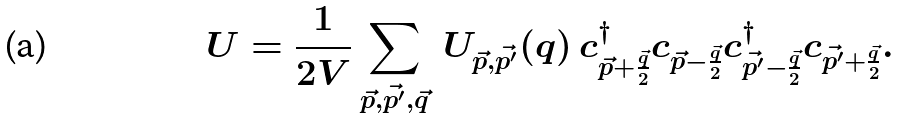<formula> <loc_0><loc_0><loc_500><loc_500>U = \frac { 1 } { 2 V } \sum _ { \vec { p } , \vec { p ^ { \prime } } , \vec { q } } \, U _ { \vec { p } , \vec { p ^ { \prime } } } ( q ) \, c ^ { \dag } _ { \vec { p } + \frac { \vec { q } } { 2 } } c _ { \vec { p } - \frac { \vec { q } } { 2 } } c ^ { \dag } _ { \vec { p ^ { \prime } } - \frac { \vec { q } } { 2 } } c _ { \vec { p ^ { \prime } } + \frac { \vec { q } } { 2 } } .</formula> 